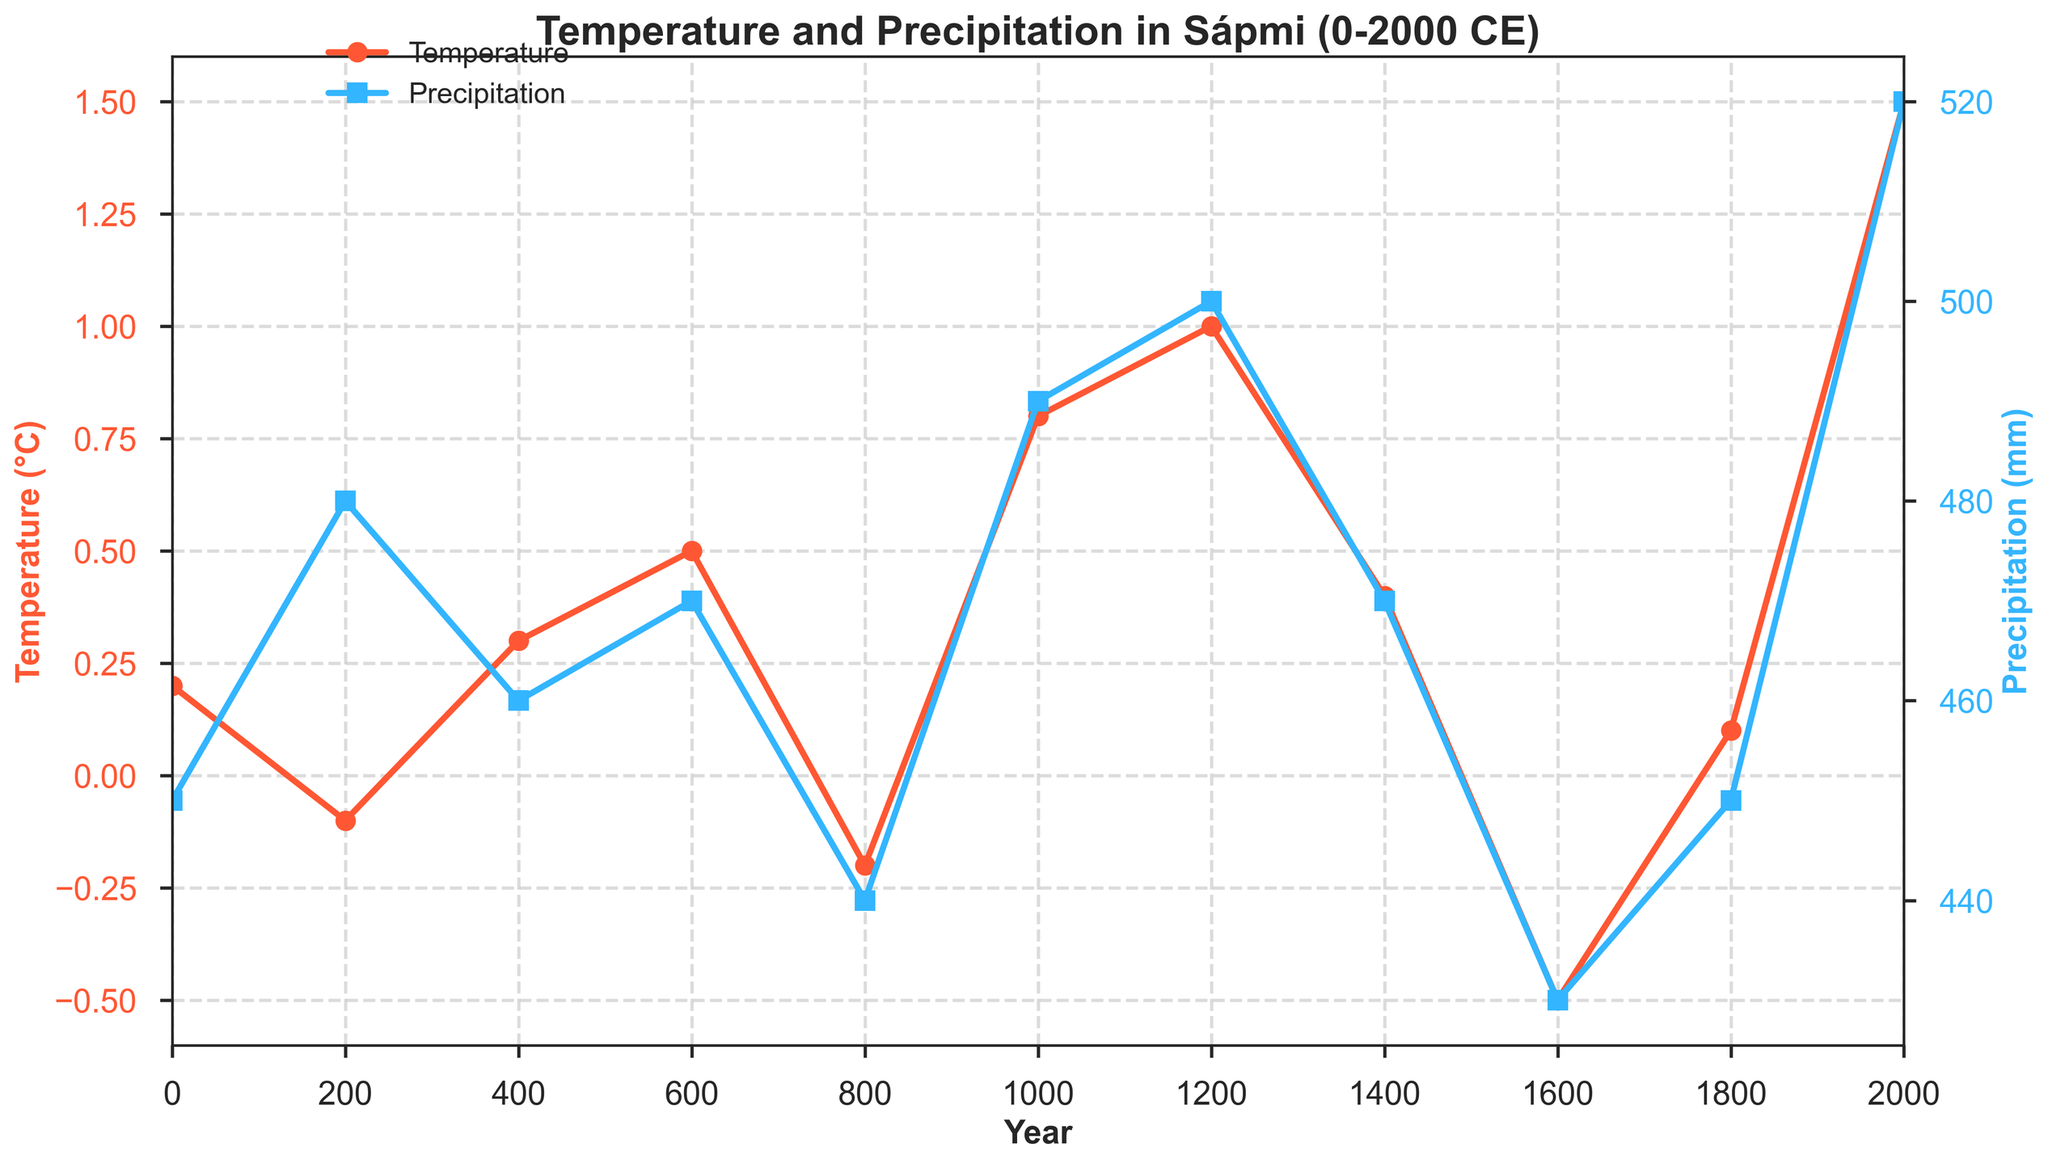What is the trend for average temperature over the past 2000 years? The average temperature starts at 0.2°C in year 0, fluctuates slightly for the next 1000 years, begins to rise significantly around year 800, and reaches its peak at 1.5°C in year 2000.
Answer: Increasing During which period was the average temperature the lowest? The lowest average temperature was at -0.5°C around year 1600.
Answer: Around year 1600 Compare the precipitation values around year 600 and year 1600. Which year had higher precipitation? The precipitation value around year 600 is 470 mm, while around year 1600 it is 430 mm. Thus, year 600 had higher precipitation.
Answer: Year 600 What is the relation between sea ice extent and average temperature over the observed period? As the average temperature increases, the sea ice extent seems to decrease. For instance, from year 0 to 2000, as the temperature rises from 0.2°C to 1.5°C, the sea ice extent shrinks from 1800000 km² to 1500000 km².
Answer: Inverse relationship How much did the standard deviation in precipitation change from year 0 to year 2000? Looking at the data, the precipitation values are 450 mm in year 0 and 520 mm in year 2000. The difference is calculated as 520 - 450 = 70 mm.
Answer: 70 mm During which centuries were average temperatures above 1.0°C? Average temperatures were above 1.0°C around the 1200s and close to 2000.
Answer: 1200s and 2000 Does the highest precipitation period coincide with the highest average temperature? The highest precipitation of 520 mm occurs in year 2000, which also has the highest average temperature of 1.5°C.
Answer: Yes Which year had the most significant difference between average temperature and precipitation? Year 2000 had a temperature of 1.5°C and precipitation of 520 mm, resulting in a significant gap, especially since it shows extreme values in terms of highs.
Answer: Year 2000 During which period was the precipitation value the lowest? Precipitation was lowest at 430 mm around year 1600.
Answer: Around year 1600 How have tree ring widths correlated with average temperature in the dataset? Generally, as average temperatures rise, tree ring widths seem to increase. For instance, in year 2000 where the temperature is highest at 1.5°C, the tree ring width is also at its highest at 1.8 mm.
Answer: Positive correlation 